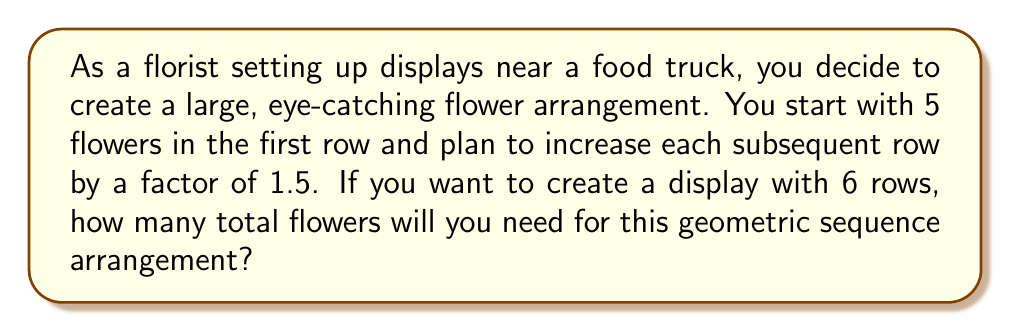Help me with this question. Let's approach this step-by-step using the formula for the sum of a geometric sequence:

1) The formula for the sum of a geometric sequence is:

   $$S_n = \frac{a(1-r^n)}{1-r}$$

   where $S_n$ is the sum, $a$ is the first term, $r$ is the common ratio, and $n$ is the number of terms.

2) In this case:
   $a = 5$ (first row has 5 flowers)
   $r = 1.5$ (each row increases by a factor of 1.5)
   $n = 6$ (6 rows in total)

3) Let's substitute these values into the formula:

   $$S_6 = \frac{5(1-1.5^6)}{1-1.5}$$

4) Calculate $1.5^6$:
   $$1.5^6 = 11.390625$$

5) Now our equation looks like:

   $$S_6 = \frac{5(1-11.390625)}{1-1.5} = \frac{5(-10.390625)}{-0.5}$$

6) Simplify:
   $$S_6 = \frac{-51.953125}{-0.5} = 103.90625$$

7) Since we can't have a fractional number of flowers, we round up to the nearest whole number.
Answer: The total number of flowers needed for the 6-row display is 104. 